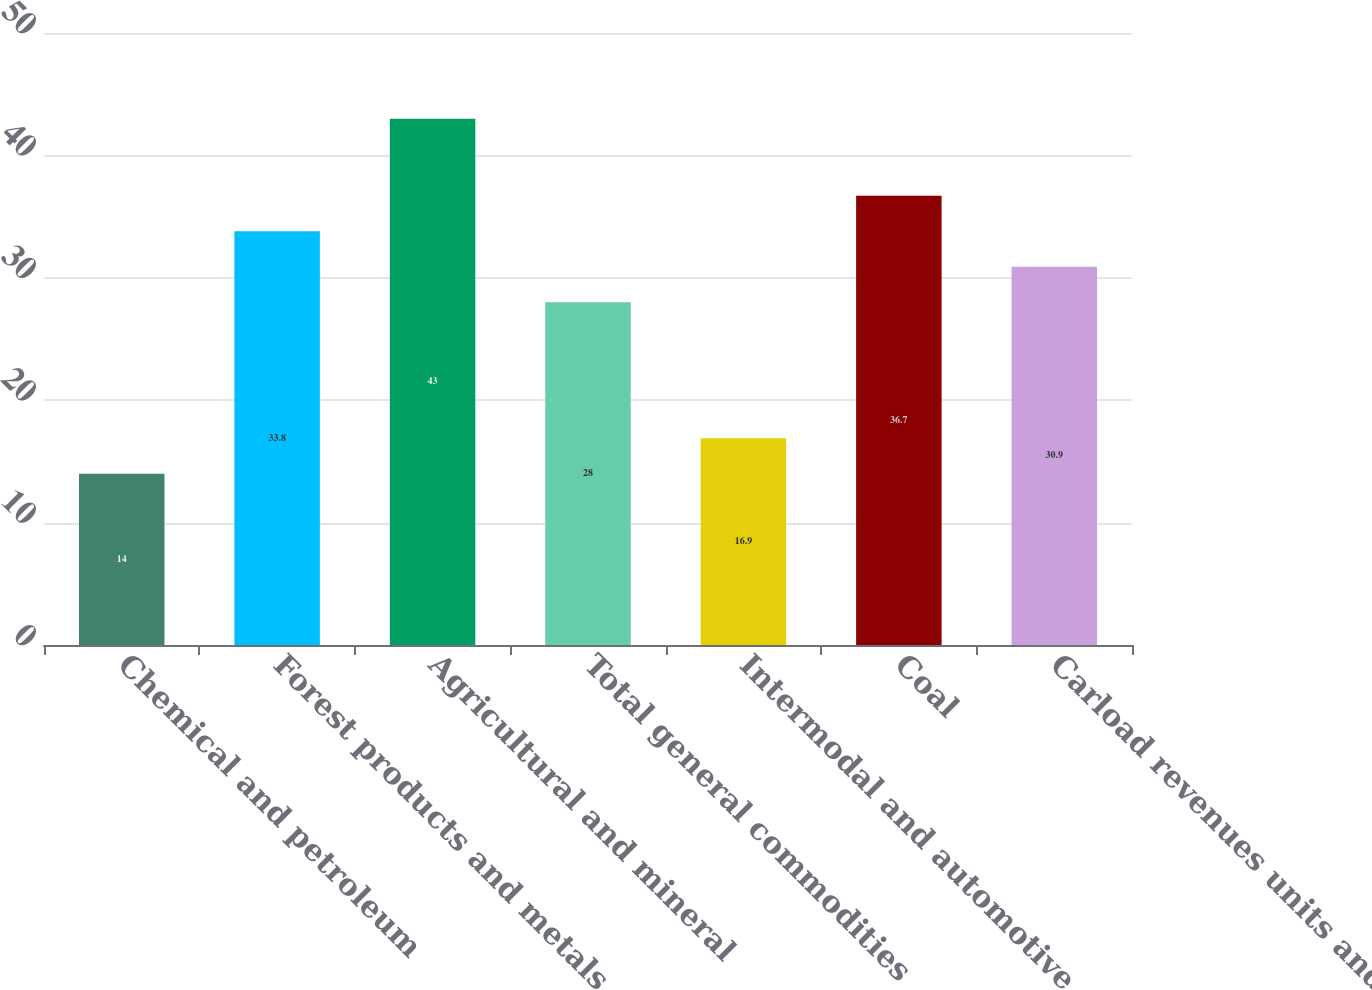<chart> <loc_0><loc_0><loc_500><loc_500><bar_chart><fcel>Chemical and petroleum<fcel>Forest products and metals<fcel>Agricultural and mineral<fcel>Total general commodities<fcel>Intermodal and automotive<fcel>Coal<fcel>Carload revenues units and<nl><fcel>14<fcel>33.8<fcel>43<fcel>28<fcel>16.9<fcel>36.7<fcel>30.9<nl></chart> 